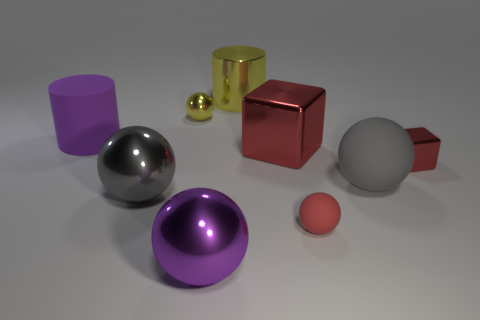How many matte things are either big brown blocks or small objects?
Offer a very short reply. 1. There is a thing that is the same color as the matte cylinder; what is its shape?
Make the answer very short. Sphere. What number of red shiny objects are the same size as the gray matte object?
Ensure brevity in your answer.  1. The large object that is both left of the big purple shiny sphere and behind the large red object is what color?
Provide a succinct answer. Purple. How many objects are large spheres or gray objects?
Ensure brevity in your answer.  3. How many big objects are purple matte things or red matte balls?
Your answer should be very brief. 1. Is there any other thing of the same color as the big matte cylinder?
Offer a very short reply. Yes. How big is the object that is in front of the tiny red block and right of the tiny red rubber object?
Provide a short and direct response. Large. Is the color of the big metal cylinder left of the tiny red rubber object the same as the tiny sphere that is in front of the big purple rubber thing?
Offer a terse response. No. What number of other objects are the same material as the small red sphere?
Your answer should be compact. 2. 